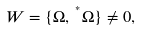<formula> <loc_0><loc_0><loc_500><loc_500>W = \{ \Omega , \, ^ { ^ { * } } \Omega \} \neq 0 , \quad</formula> 